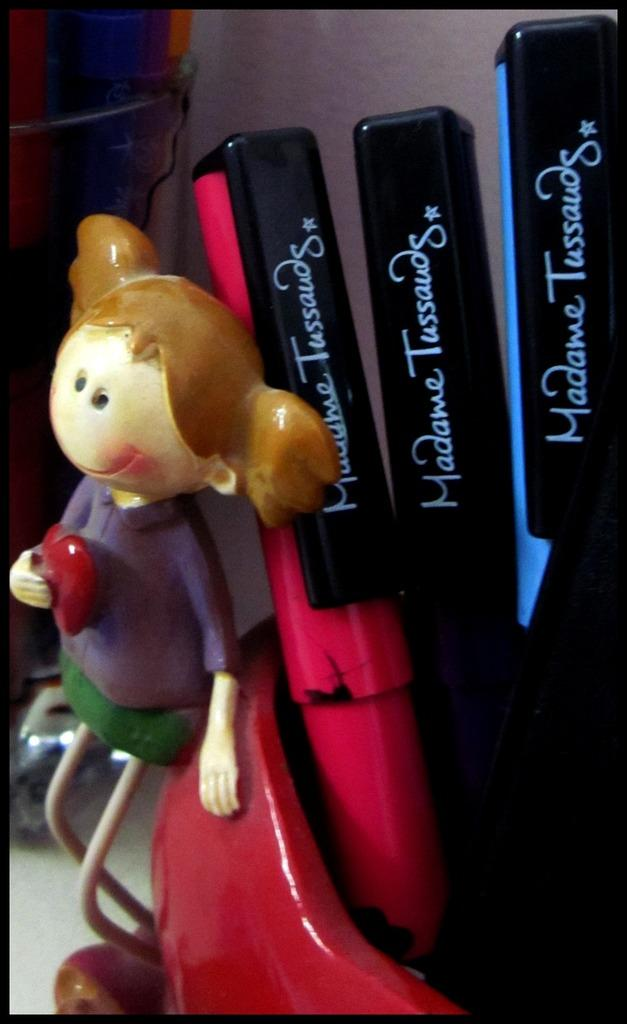<image>
Present a compact description of the photo's key features. Three pens from Madame Tussauds are in a red container with a girl figurine next to it. 